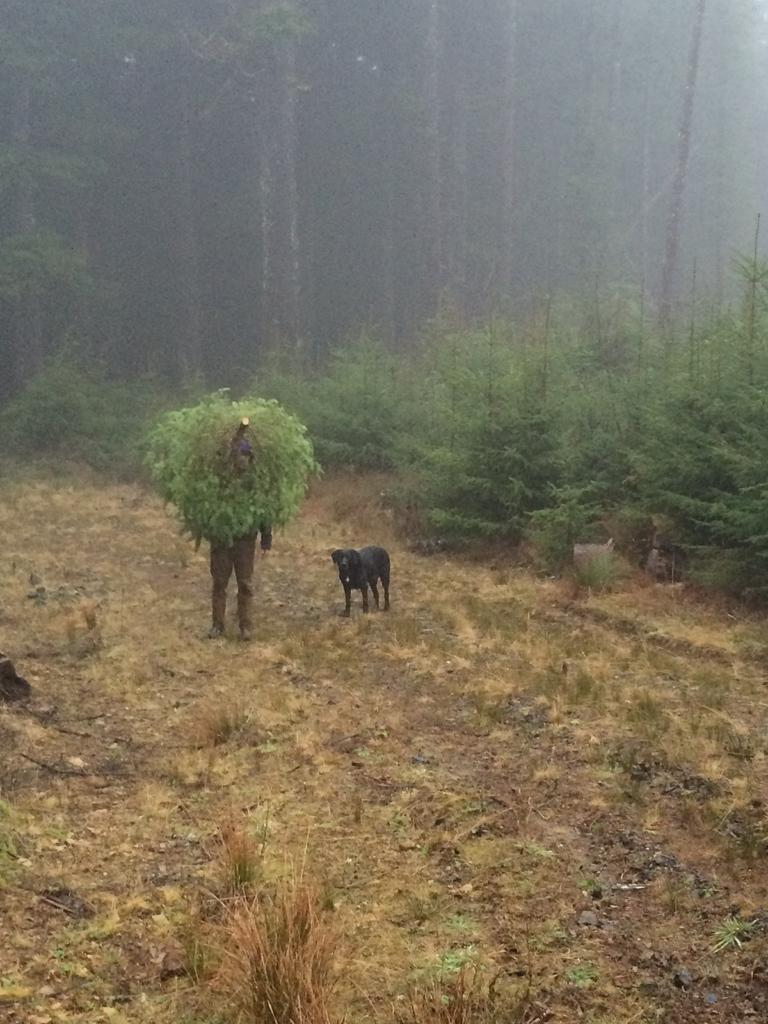What is the main subject in the image? There is a person standing in the image. What can be observed about the person's attire? The person is wearing clothes. What other living creature is present in the image? There is a dog in the image. What type of natural environment is visible in the image? There is grass, plants, and trees visible in the image. What type of hook is the person using to hold the dog in the image? There is no hook present in the image; the person is simply standing with the dog. How many pets are visible in the image? There is only one pet visible in the image, which is the dog. Where is the person's pocket located in the image? There is no mention of a pocket in the provided facts, so it cannot be determined from the image. 